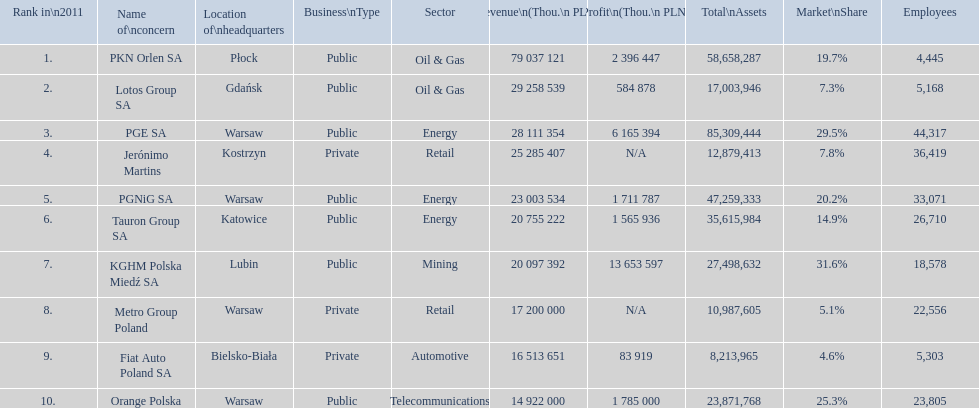Which concern's headquarters are located in warsaw? PGE SA, PGNiG SA, Metro Group Poland. Which of these listed a profit? PGE SA, PGNiG SA. Of these how many employees are in the concern with the lowest profit? 33,071. 